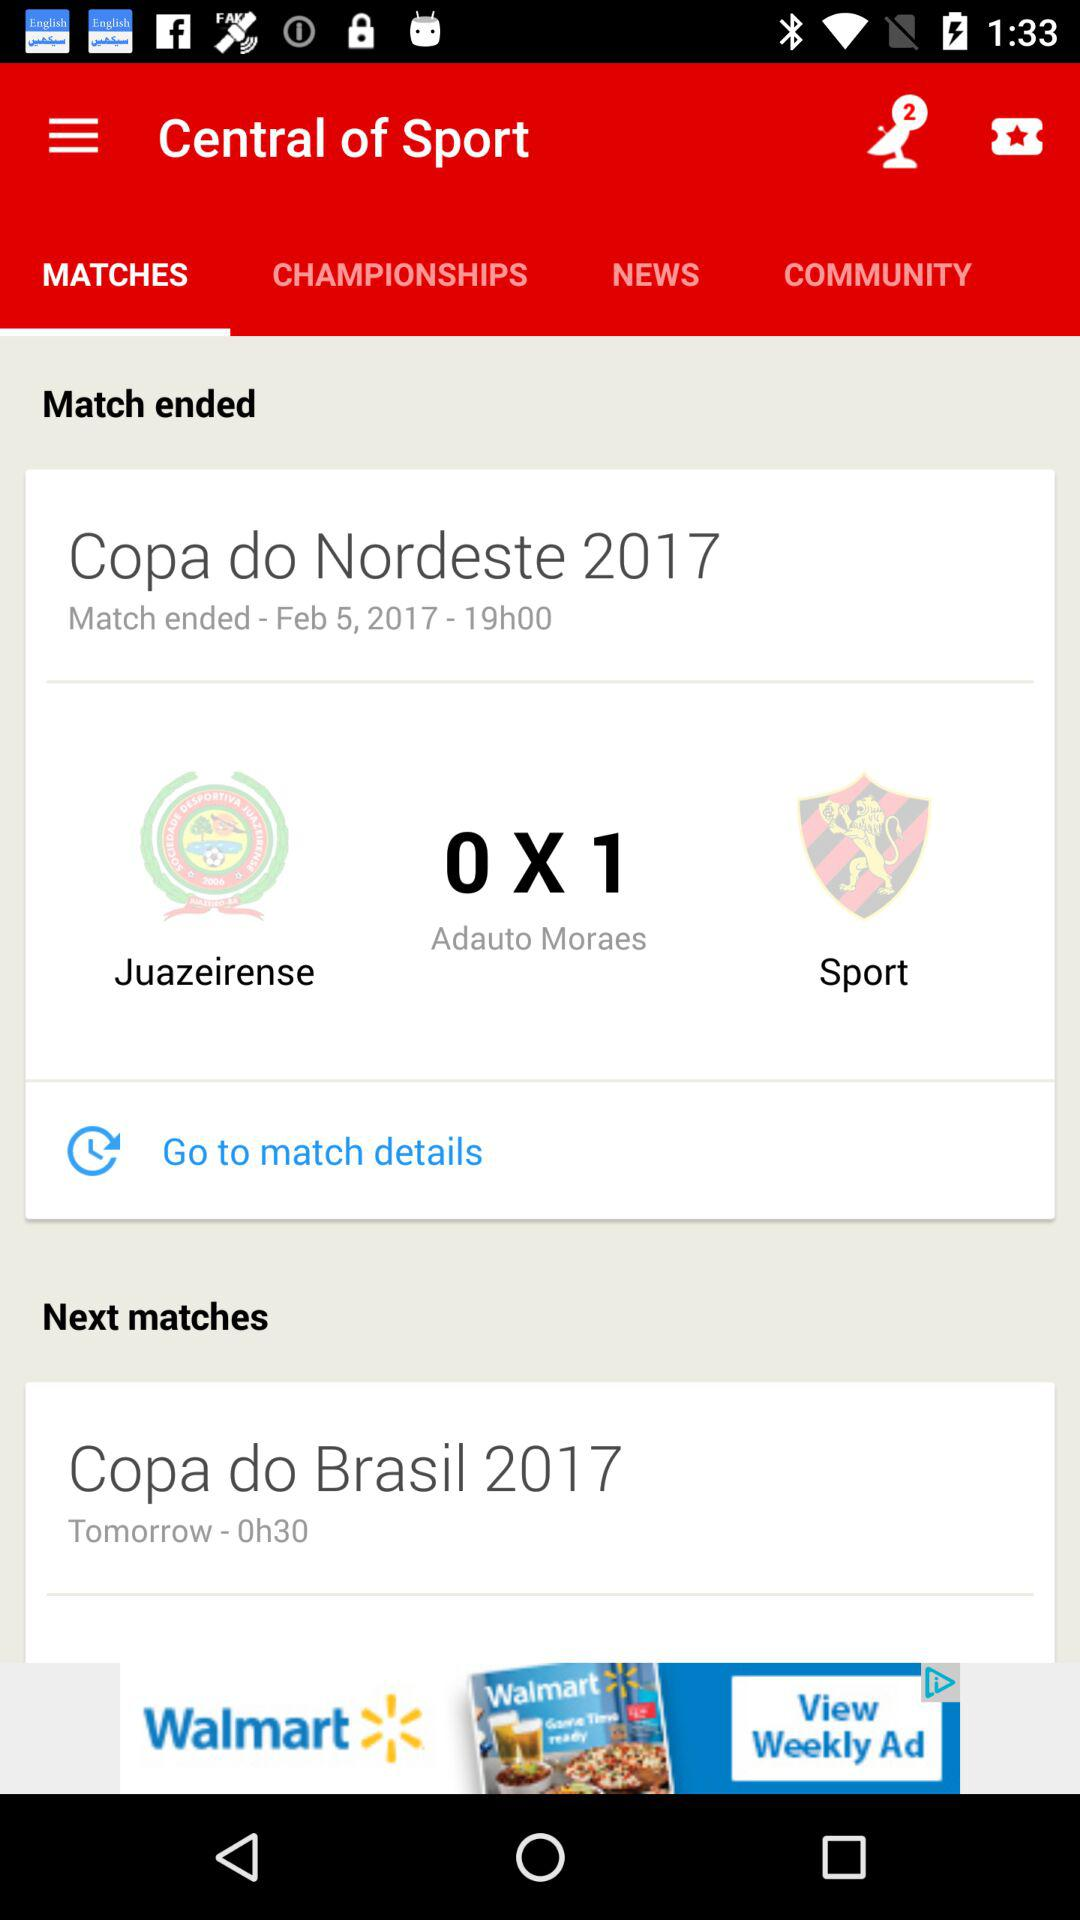How many goals were scored in the match?
Answer the question using a single word or phrase. 1 